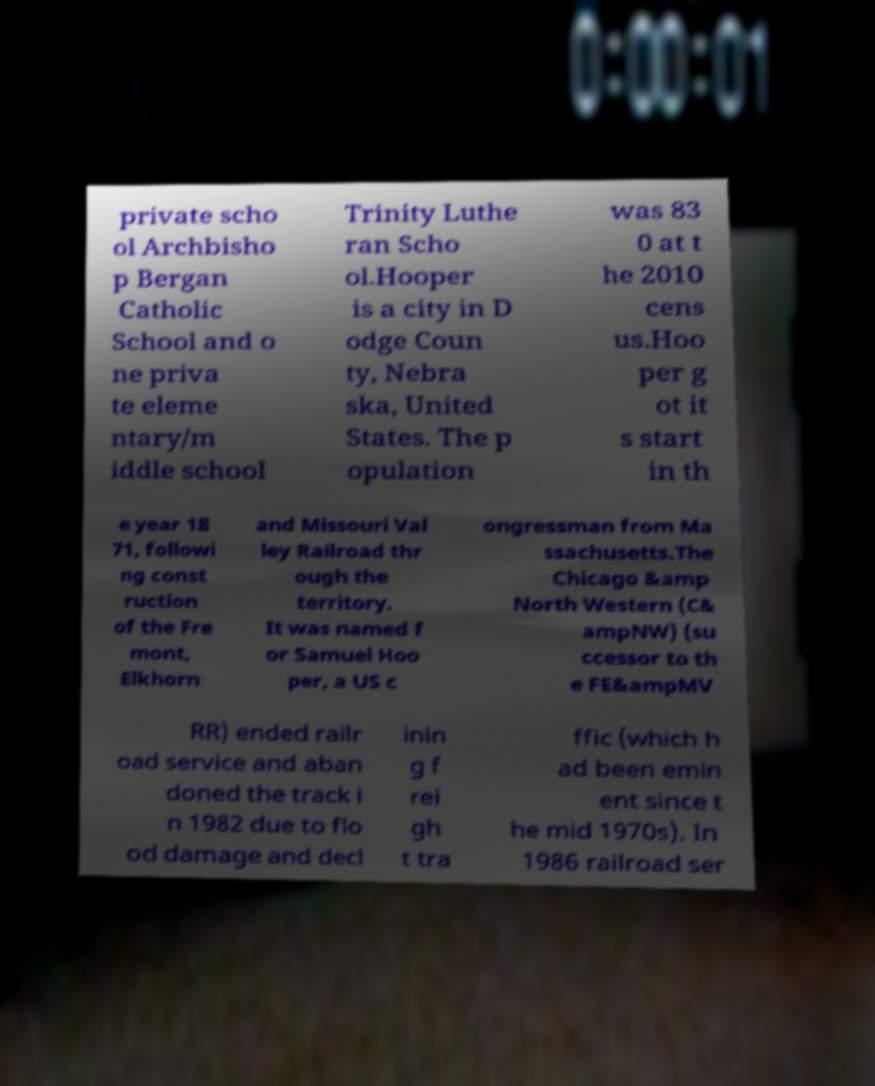Please read and relay the text visible in this image. What does it say? private scho ol Archbisho p Bergan Catholic School and o ne priva te eleme ntary/m iddle school Trinity Luthe ran Scho ol.Hooper is a city in D odge Coun ty, Nebra ska, United States. The p opulation was 83 0 at t he 2010 cens us.Hoo per g ot it s start in th e year 18 71, followi ng const ruction of the Fre mont, Elkhorn and Missouri Val ley Railroad thr ough the territory. It was named f or Samuel Hoo per, a US c ongressman from Ma ssachusetts.The Chicago &amp North Western (C& ampNW) (su ccessor to th e FE&ampMV RR) ended railr oad service and aban doned the track i n 1982 due to flo od damage and decl inin g f rei gh t tra ffic (which h ad been emin ent since t he mid 1970s). In 1986 railroad ser 